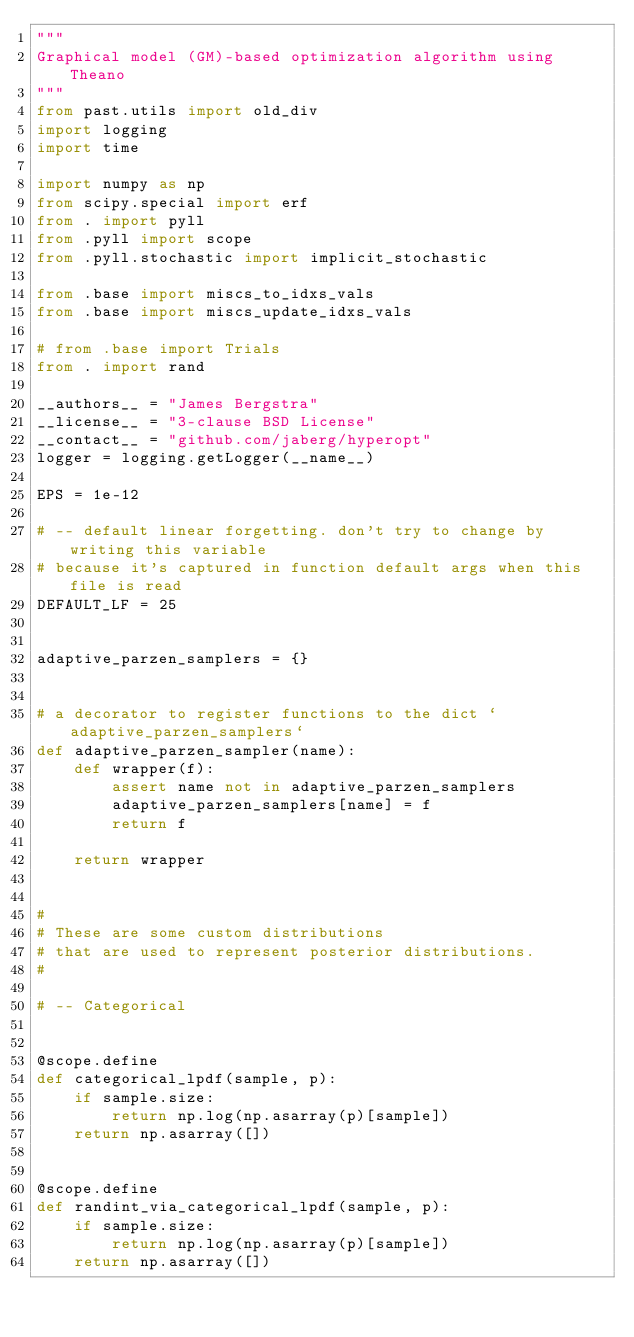<code> <loc_0><loc_0><loc_500><loc_500><_Python_>"""
Graphical model (GM)-based optimization algorithm using Theano
"""
from past.utils import old_div
import logging
import time

import numpy as np
from scipy.special import erf
from . import pyll
from .pyll import scope
from .pyll.stochastic import implicit_stochastic

from .base import miscs_to_idxs_vals
from .base import miscs_update_idxs_vals

# from .base import Trials
from . import rand

__authors__ = "James Bergstra"
__license__ = "3-clause BSD License"
__contact__ = "github.com/jaberg/hyperopt"
logger = logging.getLogger(__name__)

EPS = 1e-12

# -- default linear forgetting. don't try to change by writing this variable
# because it's captured in function default args when this file is read
DEFAULT_LF = 25


adaptive_parzen_samplers = {}


# a decorator to register functions to the dict `adaptive_parzen_samplers`
def adaptive_parzen_sampler(name):
    def wrapper(f):
        assert name not in adaptive_parzen_samplers
        adaptive_parzen_samplers[name] = f
        return f

    return wrapper


#
# These are some custom distributions
# that are used to represent posterior distributions.
#

# -- Categorical


@scope.define
def categorical_lpdf(sample, p):
    if sample.size:
        return np.log(np.asarray(p)[sample])
    return np.asarray([])


@scope.define
def randint_via_categorical_lpdf(sample, p):
    if sample.size:
        return np.log(np.asarray(p)[sample])
    return np.asarray([])

</code> 